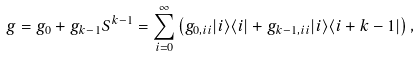Convert formula to latex. <formula><loc_0><loc_0><loc_500><loc_500>g = g _ { 0 } + g _ { k - 1 } S ^ { k - 1 } = \sum _ { i = 0 } ^ { \infty } \left ( g _ { 0 , i i } | i \rangle \langle i | + g _ { k - 1 , i i } | i \rangle \langle i + k - 1 | \right ) ,</formula> 